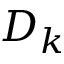Convert formula to latex. <formula><loc_0><loc_0><loc_500><loc_500>D _ { k }</formula> 